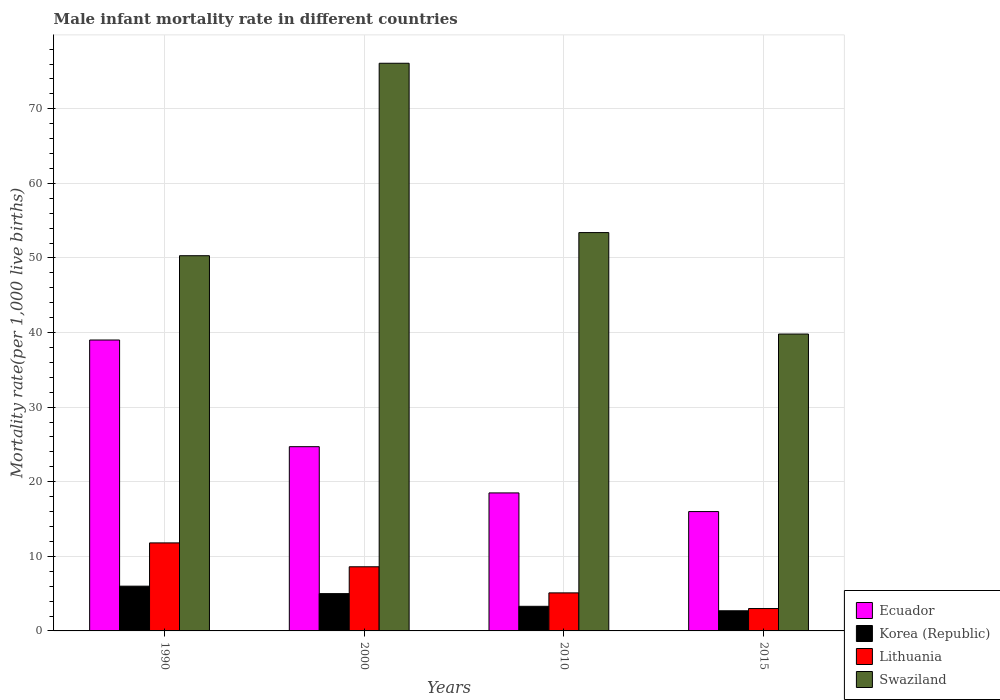How many different coloured bars are there?
Your answer should be compact. 4. How many groups of bars are there?
Offer a very short reply. 4. Are the number of bars per tick equal to the number of legend labels?
Offer a very short reply. Yes. How many bars are there on the 3rd tick from the left?
Ensure brevity in your answer.  4. What is the label of the 4th group of bars from the left?
Your answer should be compact. 2015. What is the male infant mortality rate in Swaziland in 2015?
Your answer should be very brief. 39.8. Across all years, what is the minimum male infant mortality rate in Swaziland?
Give a very brief answer. 39.8. In which year was the male infant mortality rate in Korea (Republic) minimum?
Give a very brief answer. 2015. What is the total male infant mortality rate in Swaziland in the graph?
Ensure brevity in your answer.  219.6. What is the difference between the male infant mortality rate in Lithuania in 1990 and that in 2000?
Provide a short and direct response. 3.2. What is the difference between the male infant mortality rate in Korea (Republic) in 2015 and the male infant mortality rate in Swaziland in 1990?
Keep it short and to the point. -47.6. What is the average male infant mortality rate in Lithuania per year?
Your answer should be very brief. 7.12. In the year 2010, what is the difference between the male infant mortality rate in Lithuania and male infant mortality rate in Korea (Republic)?
Your answer should be very brief. 1.8. In how many years, is the male infant mortality rate in Ecuador greater than 6?
Keep it short and to the point. 4. What is the ratio of the male infant mortality rate in Ecuador in 1990 to that in 2000?
Provide a succinct answer. 1.58. What is the difference between the highest and the lowest male infant mortality rate in Korea (Republic)?
Your answer should be compact. 3.3. In how many years, is the male infant mortality rate in Ecuador greater than the average male infant mortality rate in Ecuador taken over all years?
Your response must be concise. 2. Is the sum of the male infant mortality rate in Swaziland in 1990 and 2010 greater than the maximum male infant mortality rate in Korea (Republic) across all years?
Your answer should be compact. Yes. What does the 1st bar from the left in 2015 represents?
Your response must be concise. Ecuador. What is the difference between two consecutive major ticks on the Y-axis?
Keep it short and to the point. 10. Are the values on the major ticks of Y-axis written in scientific E-notation?
Your answer should be very brief. No. Does the graph contain any zero values?
Offer a very short reply. No. Does the graph contain grids?
Make the answer very short. Yes. How are the legend labels stacked?
Provide a succinct answer. Vertical. What is the title of the graph?
Make the answer very short. Male infant mortality rate in different countries. What is the label or title of the X-axis?
Provide a succinct answer. Years. What is the label or title of the Y-axis?
Your answer should be very brief. Mortality rate(per 1,0 live births). What is the Mortality rate(per 1,000 live births) in Ecuador in 1990?
Your answer should be very brief. 39. What is the Mortality rate(per 1,000 live births) of Korea (Republic) in 1990?
Make the answer very short. 6. What is the Mortality rate(per 1,000 live births) in Swaziland in 1990?
Your answer should be very brief. 50.3. What is the Mortality rate(per 1,000 live births) in Ecuador in 2000?
Provide a succinct answer. 24.7. What is the Mortality rate(per 1,000 live births) in Korea (Republic) in 2000?
Your response must be concise. 5. What is the Mortality rate(per 1,000 live births) in Lithuania in 2000?
Provide a succinct answer. 8.6. What is the Mortality rate(per 1,000 live births) in Swaziland in 2000?
Your answer should be compact. 76.1. What is the Mortality rate(per 1,000 live births) in Korea (Republic) in 2010?
Offer a very short reply. 3.3. What is the Mortality rate(per 1,000 live births) in Swaziland in 2010?
Provide a succinct answer. 53.4. What is the Mortality rate(per 1,000 live births) of Lithuania in 2015?
Offer a very short reply. 3. What is the Mortality rate(per 1,000 live births) of Swaziland in 2015?
Your response must be concise. 39.8. Across all years, what is the maximum Mortality rate(per 1,000 live births) in Ecuador?
Your answer should be very brief. 39. Across all years, what is the maximum Mortality rate(per 1,000 live births) of Korea (Republic)?
Give a very brief answer. 6. Across all years, what is the maximum Mortality rate(per 1,000 live births) of Swaziland?
Your response must be concise. 76.1. Across all years, what is the minimum Mortality rate(per 1,000 live births) of Swaziland?
Provide a succinct answer. 39.8. What is the total Mortality rate(per 1,000 live births) in Ecuador in the graph?
Ensure brevity in your answer.  98.2. What is the total Mortality rate(per 1,000 live births) in Swaziland in the graph?
Make the answer very short. 219.6. What is the difference between the Mortality rate(per 1,000 live births) in Ecuador in 1990 and that in 2000?
Provide a short and direct response. 14.3. What is the difference between the Mortality rate(per 1,000 live births) in Korea (Republic) in 1990 and that in 2000?
Offer a very short reply. 1. What is the difference between the Mortality rate(per 1,000 live births) in Lithuania in 1990 and that in 2000?
Keep it short and to the point. 3.2. What is the difference between the Mortality rate(per 1,000 live births) in Swaziland in 1990 and that in 2000?
Provide a short and direct response. -25.8. What is the difference between the Mortality rate(per 1,000 live births) in Ecuador in 1990 and that in 2010?
Your response must be concise. 20.5. What is the difference between the Mortality rate(per 1,000 live births) of Swaziland in 1990 and that in 2010?
Give a very brief answer. -3.1. What is the difference between the Mortality rate(per 1,000 live births) in Korea (Republic) in 1990 and that in 2015?
Keep it short and to the point. 3.3. What is the difference between the Mortality rate(per 1,000 live births) of Swaziland in 1990 and that in 2015?
Your response must be concise. 10.5. What is the difference between the Mortality rate(per 1,000 live births) of Ecuador in 2000 and that in 2010?
Offer a terse response. 6.2. What is the difference between the Mortality rate(per 1,000 live births) in Korea (Republic) in 2000 and that in 2010?
Your answer should be compact. 1.7. What is the difference between the Mortality rate(per 1,000 live births) of Lithuania in 2000 and that in 2010?
Your answer should be very brief. 3.5. What is the difference between the Mortality rate(per 1,000 live births) of Swaziland in 2000 and that in 2010?
Your response must be concise. 22.7. What is the difference between the Mortality rate(per 1,000 live births) in Korea (Republic) in 2000 and that in 2015?
Keep it short and to the point. 2.3. What is the difference between the Mortality rate(per 1,000 live births) of Swaziland in 2000 and that in 2015?
Offer a terse response. 36.3. What is the difference between the Mortality rate(per 1,000 live births) in Ecuador in 2010 and that in 2015?
Offer a terse response. 2.5. What is the difference between the Mortality rate(per 1,000 live births) of Swaziland in 2010 and that in 2015?
Provide a short and direct response. 13.6. What is the difference between the Mortality rate(per 1,000 live births) of Ecuador in 1990 and the Mortality rate(per 1,000 live births) of Korea (Republic) in 2000?
Give a very brief answer. 34. What is the difference between the Mortality rate(per 1,000 live births) in Ecuador in 1990 and the Mortality rate(per 1,000 live births) in Lithuania in 2000?
Offer a very short reply. 30.4. What is the difference between the Mortality rate(per 1,000 live births) of Ecuador in 1990 and the Mortality rate(per 1,000 live births) of Swaziland in 2000?
Give a very brief answer. -37.1. What is the difference between the Mortality rate(per 1,000 live births) in Korea (Republic) in 1990 and the Mortality rate(per 1,000 live births) in Swaziland in 2000?
Your answer should be very brief. -70.1. What is the difference between the Mortality rate(per 1,000 live births) of Lithuania in 1990 and the Mortality rate(per 1,000 live births) of Swaziland in 2000?
Ensure brevity in your answer.  -64.3. What is the difference between the Mortality rate(per 1,000 live births) of Ecuador in 1990 and the Mortality rate(per 1,000 live births) of Korea (Republic) in 2010?
Provide a succinct answer. 35.7. What is the difference between the Mortality rate(per 1,000 live births) in Ecuador in 1990 and the Mortality rate(per 1,000 live births) in Lithuania in 2010?
Offer a terse response. 33.9. What is the difference between the Mortality rate(per 1,000 live births) of Ecuador in 1990 and the Mortality rate(per 1,000 live births) of Swaziland in 2010?
Provide a succinct answer. -14.4. What is the difference between the Mortality rate(per 1,000 live births) in Korea (Republic) in 1990 and the Mortality rate(per 1,000 live births) in Lithuania in 2010?
Your response must be concise. 0.9. What is the difference between the Mortality rate(per 1,000 live births) of Korea (Republic) in 1990 and the Mortality rate(per 1,000 live births) of Swaziland in 2010?
Provide a succinct answer. -47.4. What is the difference between the Mortality rate(per 1,000 live births) of Lithuania in 1990 and the Mortality rate(per 1,000 live births) of Swaziland in 2010?
Keep it short and to the point. -41.6. What is the difference between the Mortality rate(per 1,000 live births) of Ecuador in 1990 and the Mortality rate(per 1,000 live births) of Korea (Republic) in 2015?
Keep it short and to the point. 36.3. What is the difference between the Mortality rate(per 1,000 live births) in Ecuador in 1990 and the Mortality rate(per 1,000 live births) in Lithuania in 2015?
Offer a terse response. 36. What is the difference between the Mortality rate(per 1,000 live births) in Korea (Republic) in 1990 and the Mortality rate(per 1,000 live births) in Swaziland in 2015?
Provide a short and direct response. -33.8. What is the difference between the Mortality rate(per 1,000 live births) in Ecuador in 2000 and the Mortality rate(per 1,000 live births) in Korea (Republic) in 2010?
Give a very brief answer. 21.4. What is the difference between the Mortality rate(per 1,000 live births) in Ecuador in 2000 and the Mortality rate(per 1,000 live births) in Lithuania in 2010?
Provide a succinct answer. 19.6. What is the difference between the Mortality rate(per 1,000 live births) of Ecuador in 2000 and the Mortality rate(per 1,000 live births) of Swaziland in 2010?
Keep it short and to the point. -28.7. What is the difference between the Mortality rate(per 1,000 live births) of Korea (Republic) in 2000 and the Mortality rate(per 1,000 live births) of Swaziland in 2010?
Your answer should be compact. -48.4. What is the difference between the Mortality rate(per 1,000 live births) in Lithuania in 2000 and the Mortality rate(per 1,000 live births) in Swaziland in 2010?
Your response must be concise. -44.8. What is the difference between the Mortality rate(per 1,000 live births) in Ecuador in 2000 and the Mortality rate(per 1,000 live births) in Korea (Republic) in 2015?
Keep it short and to the point. 22. What is the difference between the Mortality rate(per 1,000 live births) in Ecuador in 2000 and the Mortality rate(per 1,000 live births) in Lithuania in 2015?
Your answer should be compact. 21.7. What is the difference between the Mortality rate(per 1,000 live births) of Ecuador in 2000 and the Mortality rate(per 1,000 live births) of Swaziland in 2015?
Provide a short and direct response. -15.1. What is the difference between the Mortality rate(per 1,000 live births) of Korea (Republic) in 2000 and the Mortality rate(per 1,000 live births) of Swaziland in 2015?
Offer a very short reply. -34.8. What is the difference between the Mortality rate(per 1,000 live births) of Lithuania in 2000 and the Mortality rate(per 1,000 live births) of Swaziland in 2015?
Your answer should be compact. -31.2. What is the difference between the Mortality rate(per 1,000 live births) of Ecuador in 2010 and the Mortality rate(per 1,000 live births) of Lithuania in 2015?
Ensure brevity in your answer.  15.5. What is the difference between the Mortality rate(per 1,000 live births) of Ecuador in 2010 and the Mortality rate(per 1,000 live births) of Swaziland in 2015?
Offer a terse response. -21.3. What is the difference between the Mortality rate(per 1,000 live births) in Korea (Republic) in 2010 and the Mortality rate(per 1,000 live births) in Lithuania in 2015?
Your answer should be compact. 0.3. What is the difference between the Mortality rate(per 1,000 live births) of Korea (Republic) in 2010 and the Mortality rate(per 1,000 live births) of Swaziland in 2015?
Make the answer very short. -36.5. What is the difference between the Mortality rate(per 1,000 live births) of Lithuania in 2010 and the Mortality rate(per 1,000 live births) of Swaziland in 2015?
Provide a succinct answer. -34.7. What is the average Mortality rate(per 1,000 live births) in Ecuador per year?
Provide a succinct answer. 24.55. What is the average Mortality rate(per 1,000 live births) of Korea (Republic) per year?
Keep it short and to the point. 4.25. What is the average Mortality rate(per 1,000 live births) in Lithuania per year?
Make the answer very short. 7.12. What is the average Mortality rate(per 1,000 live births) in Swaziland per year?
Your answer should be compact. 54.9. In the year 1990, what is the difference between the Mortality rate(per 1,000 live births) in Ecuador and Mortality rate(per 1,000 live births) in Lithuania?
Your answer should be compact. 27.2. In the year 1990, what is the difference between the Mortality rate(per 1,000 live births) of Ecuador and Mortality rate(per 1,000 live births) of Swaziland?
Your answer should be very brief. -11.3. In the year 1990, what is the difference between the Mortality rate(per 1,000 live births) of Korea (Republic) and Mortality rate(per 1,000 live births) of Lithuania?
Your response must be concise. -5.8. In the year 1990, what is the difference between the Mortality rate(per 1,000 live births) of Korea (Republic) and Mortality rate(per 1,000 live births) of Swaziland?
Your answer should be compact. -44.3. In the year 1990, what is the difference between the Mortality rate(per 1,000 live births) in Lithuania and Mortality rate(per 1,000 live births) in Swaziland?
Offer a terse response. -38.5. In the year 2000, what is the difference between the Mortality rate(per 1,000 live births) in Ecuador and Mortality rate(per 1,000 live births) in Korea (Republic)?
Offer a very short reply. 19.7. In the year 2000, what is the difference between the Mortality rate(per 1,000 live births) in Ecuador and Mortality rate(per 1,000 live births) in Swaziland?
Your response must be concise. -51.4. In the year 2000, what is the difference between the Mortality rate(per 1,000 live births) of Korea (Republic) and Mortality rate(per 1,000 live births) of Lithuania?
Provide a short and direct response. -3.6. In the year 2000, what is the difference between the Mortality rate(per 1,000 live births) of Korea (Republic) and Mortality rate(per 1,000 live births) of Swaziland?
Your answer should be very brief. -71.1. In the year 2000, what is the difference between the Mortality rate(per 1,000 live births) of Lithuania and Mortality rate(per 1,000 live births) of Swaziland?
Offer a very short reply. -67.5. In the year 2010, what is the difference between the Mortality rate(per 1,000 live births) of Ecuador and Mortality rate(per 1,000 live births) of Korea (Republic)?
Your answer should be compact. 15.2. In the year 2010, what is the difference between the Mortality rate(per 1,000 live births) of Ecuador and Mortality rate(per 1,000 live births) of Swaziland?
Keep it short and to the point. -34.9. In the year 2010, what is the difference between the Mortality rate(per 1,000 live births) in Korea (Republic) and Mortality rate(per 1,000 live births) in Swaziland?
Your response must be concise. -50.1. In the year 2010, what is the difference between the Mortality rate(per 1,000 live births) of Lithuania and Mortality rate(per 1,000 live births) of Swaziland?
Provide a succinct answer. -48.3. In the year 2015, what is the difference between the Mortality rate(per 1,000 live births) of Ecuador and Mortality rate(per 1,000 live births) of Korea (Republic)?
Ensure brevity in your answer.  13.3. In the year 2015, what is the difference between the Mortality rate(per 1,000 live births) of Ecuador and Mortality rate(per 1,000 live births) of Lithuania?
Give a very brief answer. 13. In the year 2015, what is the difference between the Mortality rate(per 1,000 live births) in Ecuador and Mortality rate(per 1,000 live births) in Swaziland?
Provide a succinct answer. -23.8. In the year 2015, what is the difference between the Mortality rate(per 1,000 live births) of Korea (Republic) and Mortality rate(per 1,000 live births) of Swaziland?
Give a very brief answer. -37.1. In the year 2015, what is the difference between the Mortality rate(per 1,000 live births) of Lithuania and Mortality rate(per 1,000 live births) of Swaziland?
Your answer should be compact. -36.8. What is the ratio of the Mortality rate(per 1,000 live births) in Ecuador in 1990 to that in 2000?
Offer a terse response. 1.58. What is the ratio of the Mortality rate(per 1,000 live births) of Korea (Republic) in 1990 to that in 2000?
Offer a very short reply. 1.2. What is the ratio of the Mortality rate(per 1,000 live births) in Lithuania in 1990 to that in 2000?
Your response must be concise. 1.37. What is the ratio of the Mortality rate(per 1,000 live births) in Swaziland in 1990 to that in 2000?
Make the answer very short. 0.66. What is the ratio of the Mortality rate(per 1,000 live births) in Ecuador in 1990 to that in 2010?
Provide a short and direct response. 2.11. What is the ratio of the Mortality rate(per 1,000 live births) of Korea (Republic) in 1990 to that in 2010?
Keep it short and to the point. 1.82. What is the ratio of the Mortality rate(per 1,000 live births) of Lithuania in 1990 to that in 2010?
Offer a terse response. 2.31. What is the ratio of the Mortality rate(per 1,000 live births) of Swaziland in 1990 to that in 2010?
Offer a very short reply. 0.94. What is the ratio of the Mortality rate(per 1,000 live births) in Ecuador in 1990 to that in 2015?
Ensure brevity in your answer.  2.44. What is the ratio of the Mortality rate(per 1,000 live births) of Korea (Republic) in 1990 to that in 2015?
Offer a terse response. 2.22. What is the ratio of the Mortality rate(per 1,000 live births) in Lithuania in 1990 to that in 2015?
Your answer should be very brief. 3.93. What is the ratio of the Mortality rate(per 1,000 live births) in Swaziland in 1990 to that in 2015?
Offer a very short reply. 1.26. What is the ratio of the Mortality rate(per 1,000 live births) of Ecuador in 2000 to that in 2010?
Provide a short and direct response. 1.34. What is the ratio of the Mortality rate(per 1,000 live births) in Korea (Republic) in 2000 to that in 2010?
Your answer should be compact. 1.52. What is the ratio of the Mortality rate(per 1,000 live births) of Lithuania in 2000 to that in 2010?
Ensure brevity in your answer.  1.69. What is the ratio of the Mortality rate(per 1,000 live births) of Swaziland in 2000 to that in 2010?
Make the answer very short. 1.43. What is the ratio of the Mortality rate(per 1,000 live births) in Ecuador in 2000 to that in 2015?
Keep it short and to the point. 1.54. What is the ratio of the Mortality rate(per 1,000 live births) of Korea (Republic) in 2000 to that in 2015?
Your response must be concise. 1.85. What is the ratio of the Mortality rate(per 1,000 live births) in Lithuania in 2000 to that in 2015?
Offer a terse response. 2.87. What is the ratio of the Mortality rate(per 1,000 live births) in Swaziland in 2000 to that in 2015?
Your answer should be very brief. 1.91. What is the ratio of the Mortality rate(per 1,000 live births) of Ecuador in 2010 to that in 2015?
Make the answer very short. 1.16. What is the ratio of the Mortality rate(per 1,000 live births) in Korea (Republic) in 2010 to that in 2015?
Offer a terse response. 1.22. What is the ratio of the Mortality rate(per 1,000 live births) of Lithuania in 2010 to that in 2015?
Provide a succinct answer. 1.7. What is the ratio of the Mortality rate(per 1,000 live births) of Swaziland in 2010 to that in 2015?
Ensure brevity in your answer.  1.34. What is the difference between the highest and the second highest Mortality rate(per 1,000 live births) in Ecuador?
Make the answer very short. 14.3. What is the difference between the highest and the second highest Mortality rate(per 1,000 live births) in Lithuania?
Provide a succinct answer. 3.2. What is the difference between the highest and the second highest Mortality rate(per 1,000 live births) in Swaziland?
Ensure brevity in your answer.  22.7. What is the difference between the highest and the lowest Mortality rate(per 1,000 live births) in Korea (Republic)?
Provide a short and direct response. 3.3. What is the difference between the highest and the lowest Mortality rate(per 1,000 live births) of Lithuania?
Provide a succinct answer. 8.8. What is the difference between the highest and the lowest Mortality rate(per 1,000 live births) of Swaziland?
Your response must be concise. 36.3. 